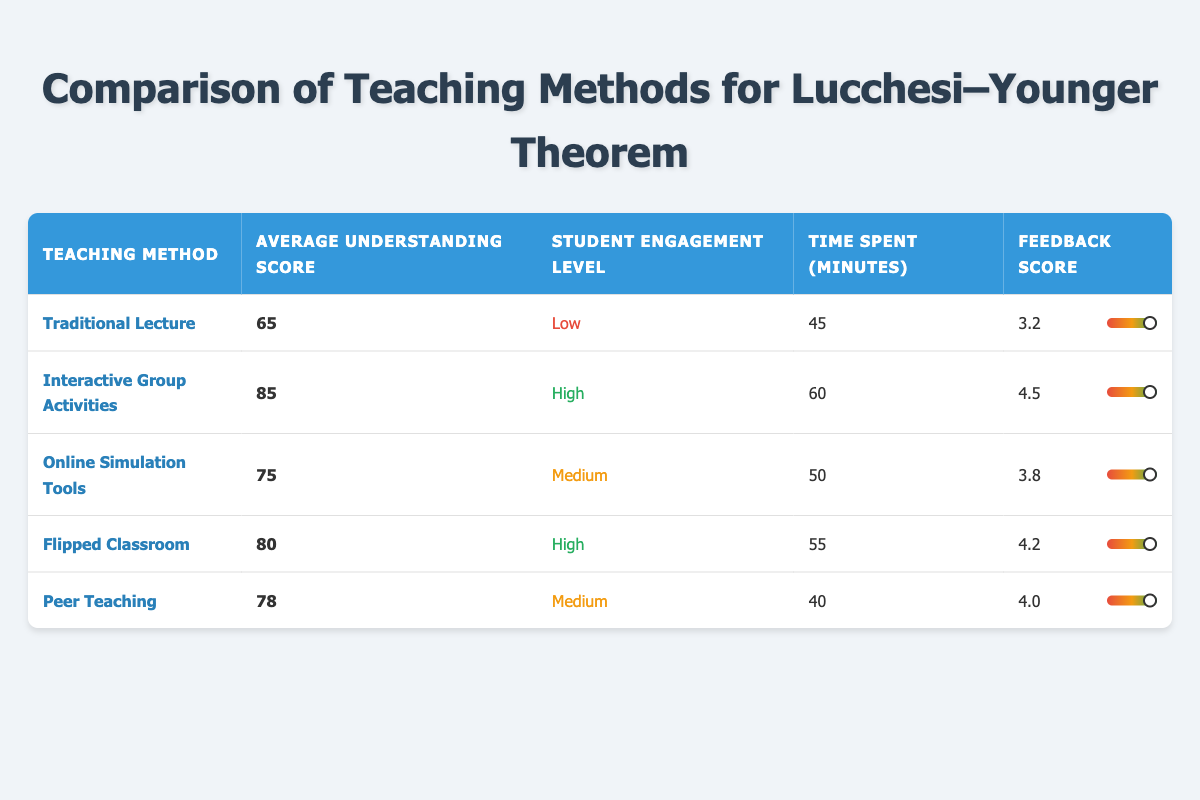What is the average understanding score for the Interactive Group Activities method? The average understanding score for the Interactive Group Activities method is directly listed in the table as 85.
Answer: 85 Which teaching method has the highest feedback score? By evaluating the feedback scores listed in the table, Interactive Group Activities has the highest score at 4.5.
Answer: Interactive Group Activities What is the total time spent on the topic by the Peer Teaching method compared to the Traditional Lecture? The time spent on the Peer Teaching method is 40 minutes, while the Traditional Lecture is 45 minutes. The difference is calculated as 45 - 40 = 5 minutes.
Answer: 5 minutes Is the engagement level for Online Simulation Tools considered high? The engagement level for Online Simulation Tools is labeled as Medium, which means it is not high.
Answer: No What is the average understanding score of all teaching methods combined? To find the average, sum the understanding scores: 65 + 85 + 75 + 80 + 78 = 383. Divide this sum by the number of methods (5): 383 / 5 = 76.6.
Answer: 76.6 Which teaching method has the lowest student engagement level and what is the level? The Traditional Lecture method has the lowest student engagement level, which is categorized as Low, as shown in the table.
Answer: Traditional Lecture, Low What is the difference in average understanding scores between the Flipped Classroom and the Peer Teaching methods? The average understanding score for the Flipped Classroom is 80, and for Peer Teaching, it is 78. The difference is calculated as 80 - 78 = 2.
Answer: 2 How many methods have a student engagement level categorized as High? The table shows there are two methods with a High engagement level: Interactive Group Activities and Flipped Classroom.
Answer: 2 Which teaching method requires the most time spent on the topic and how much is it? The method that requires the most time spent is Interactive Group Activities at 60 minutes, as indicated in the table.
Answer: Interactive Group Activities, 60 minutes 